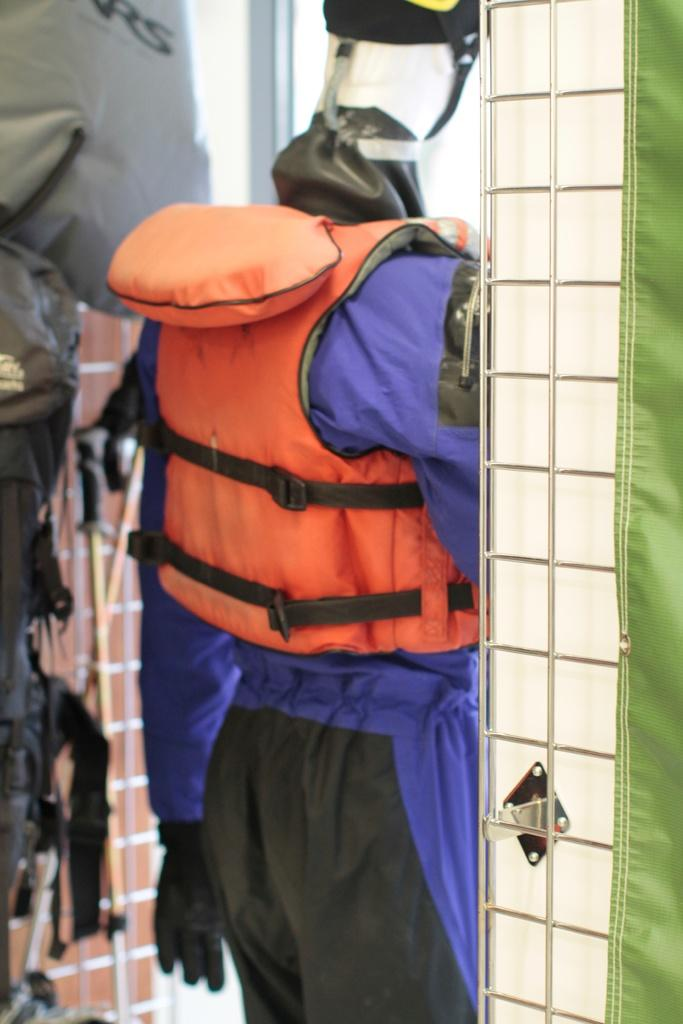What is the main subject of the image? There is a mannequin in the image. What is the mannequin wearing? The mannequin is wearing a jacket. What can be seen in the background of the image? There are sticks visible in the background of the image. What is on the mannequin's head? There is a helmet on the mannequin's head. What type of bead is being used for the observation on the sidewalk in the image? There is no bead or observation on the sidewalk in the image. 